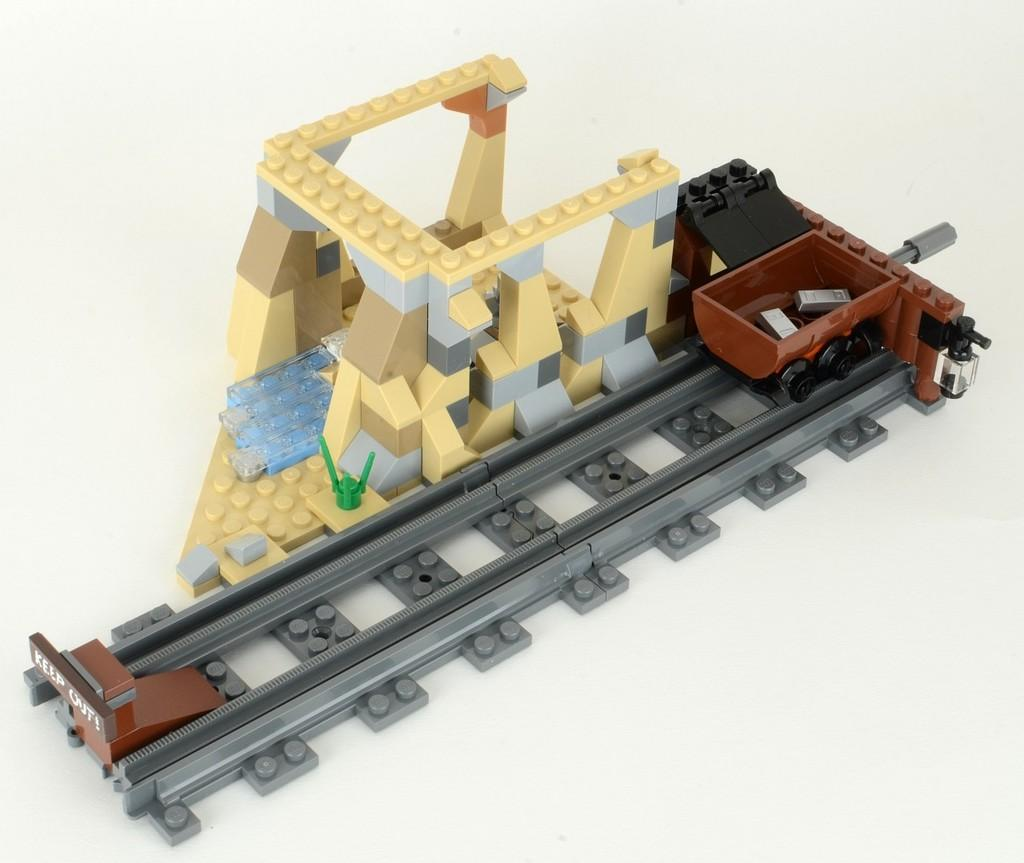What type of toys are visible in the image? There are Lego toys in the image. Where are the Lego toys placed? The Lego toys are placed on a surface. What can be seen in the image besides the Lego toys? There is a track and a trolley present on the track in the image. What type of bone can be seen in the image? There is no bone present in the image; it features Lego toys, a track, and a trolley. Can you tell me who gave their approval for the Lego toys in the image? There is no information about approval given for the Lego toys in the image. 